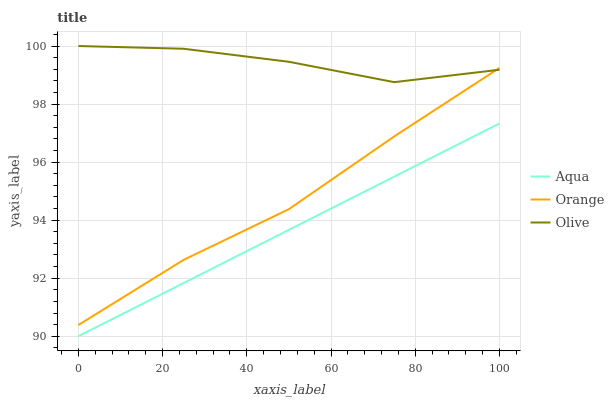Does Aqua have the minimum area under the curve?
Answer yes or no. Yes. Does Olive have the maximum area under the curve?
Answer yes or no. Yes. Does Olive have the minimum area under the curve?
Answer yes or no. No. Does Aqua have the maximum area under the curve?
Answer yes or no. No. Is Aqua the smoothest?
Answer yes or no. Yes. Is Olive the roughest?
Answer yes or no. Yes. Is Olive the smoothest?
Answer yes or no. No. Is Aqua the roughest?
Answer yes or no. No. Does Aqua have the lowest value?
Answer yes or no. Yes. Does Olive have the lowest value?
Answer yes or no. No. Does Olive have the highest value?
Answer yes or no. Yes. Does Aqua have the highest value?
Answer yes or no. No. Is Aqua less than Orange?
Answer yes or no. Yes. Is Orange greater than Aqua?
Answer yes or no. Yes. Does Orange intersect Olive?
Answer yes or no. Yes. Is Orange less than Olive?
Answer yes or no. No. Is Orange greater than Olive?
Answer yes or no. No. Does Aqua intersect Orange?
Answer yes or no. No. 